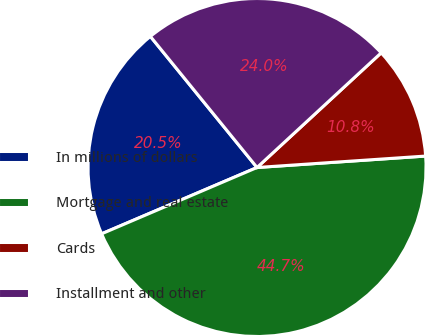Convert chart. <chart><loc_0><loc_0><loc_500><loc_500><pie_chart><fcel>In millions of dollars<fcel>Mortgage and real estate<fcel>Cards<fcel>Installment and other<nl><fcel>20.55%<fcel>44.66%<fcel>10.79%<fcel>24.0%<nl></chart> 